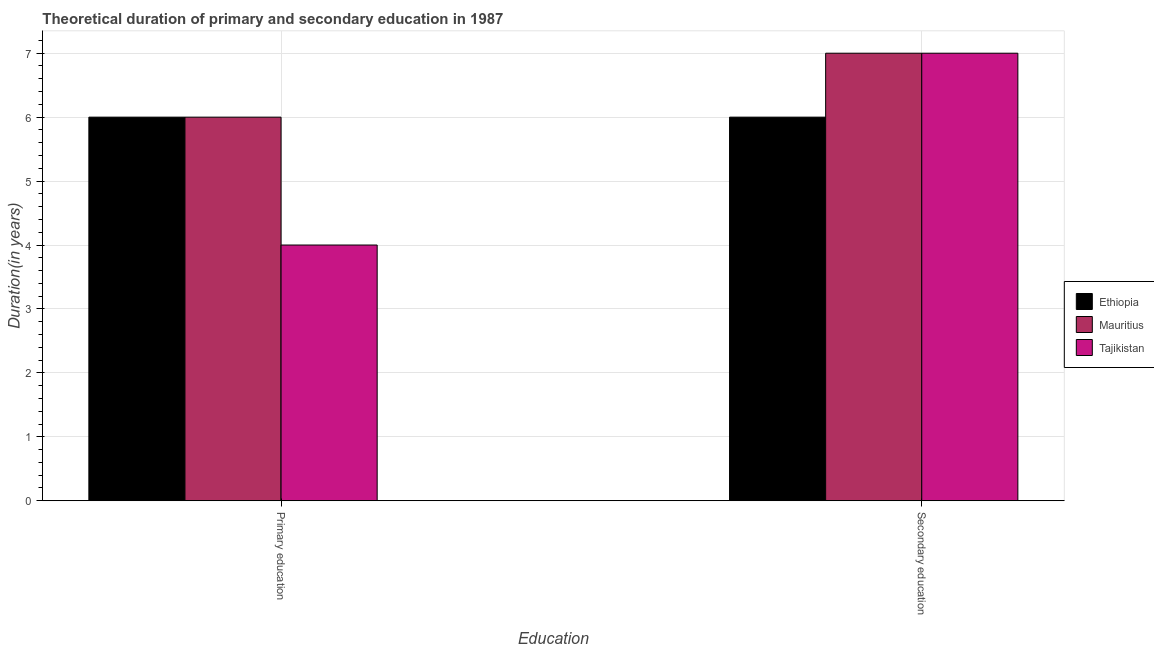Are the number of bars per tick equal to the number of legend labels?
Offer a terse response. Yes. Are the number of bars on each tick of the X-axis equal?
Provide a short and direct response. Yes. What is the duration of secondary education in Ethiopia?
Your answer should be very brief. 6. Across all countries, what is the minimum duration of secondary education?
Keep it short and to the point. 6. In which country was the duration of primary education maximum?
Your response must be concise. Ethiopia. In which country was the duration of secondary education minimum?
Provide a succinct answer. Ethiopia. What is the total duration of secondary education in the graph?
Keep it short and to the point. 20. What is the difference between the duration of primary education in Tajikistan and that in Ethiopia?
Offer a very short reply. -2. What is the difference between the duration of secondary education in Ethiopia and the duration of primary education in Mauritius?
Provide a short and direct response. 0. What is the average duration of secondary education per country?
Ensure brevity in your answer.  6.67. In how many countries, is the duration of secondary education greater than 1.6 years?
Your answer should be very brief. 3. Is the duration of primary education in Ethiopia less than that in Tajikistan?
Your answer should be very brief. No. In how many countries, is the duration of secondary education greater than the average duration of secondary education taken over all countries?
Provide a succinct answer. 2. What does the 1st bar from the left in Primary education represents?
Provide a succinct answer. Ethiopia. What does the 2nd bar from the right in Primary education represents?
Your answer should be very brief. Mauritius. Are all the bars in the graph horizontal?
Offer a terse response. No. Does the graph contain grids?
Provide a short and direct response. Yes. How many legend labels are there?
Your answer should be compact. 3. What is the title of the graph?
Offer a terse response. Theoretical duration of primary and secondary education in 1987. What is the label or title of the X-axis?
Your response must be concise. Education. What is the label or title of the Y-axis?
Your answer should be compact. Duration(in years). What is the Duration(in years) in Tajikistan in Primary education?
Offer a very short reply. 4. What is the Duration(in years) of Mauritius in Secondary education?
Ensure brevity in your answer.  7. Across all Education, what is the maximum Duration(in years) of Ethiopia?
Keep it short and to the point. 6. Across all Education, what is the minimum Duration(in years) of Mauritius?
Keep it short and to the point. 6. What is the total Duration(in years) in Ethiopia in the graph?
Keep it short and to the point. 12. What is the total Duration(in years) of Tajikistan in the graph?
Ensure brevity in your answer.  11. What is the difference between the Duration(in years) in Ethiopia in Primary education and the Duration(in years) in Tajikistan in Secondary education?
Make the answer very short. -1. What is the difference between the Duration(in years) in Ethiopia and Duration(in years) in Mauritius in Primary education?
Give a very brief answer. 0. What is the difference between the Duration(in years) in Mauritius and Duration(in years) in Tajikistan in Primary education?
Your response must be concise. 2. What is the difference between the Duration(in years) of Ethiopia and Duration(in years) of Mauritius in Secondary education?
Provide a short and direct response. -1. What is the difference between the Duration(in years) in Mauritius and Duration(in years) in Tajikistan in Secondary education?
Provide a succinct answer. 0. What is the ratio of the Duration(in years) of Ethiopia in Primary education to that in Secondary education?
Make the answer very short. 1. What is the ratio of the Duration(in years) of Mauritius in Primary education to that in Secondary education?
Make the answer very short. 0.86. What is the ratio of the Duration(in years) of Tajikistan in Primary education to that in Secondary education?
Offer a very short reply. 0.57. What is the difference between the highest and the second highest Duration(in years) of Ethiopia?
Provide a succinct answer. 0. What is the difference between the highest and the second highest Duration(in years) of Tajikistan?
Give a very brief answer. 3. What is the difference between the highest and the lowest Duration(in years) of Mauritius?
Offer a terse response. 1. What is the difference between the highest and the lowest Duration(in years) in Tajikistan?
Provide a short and direct response. 3. 